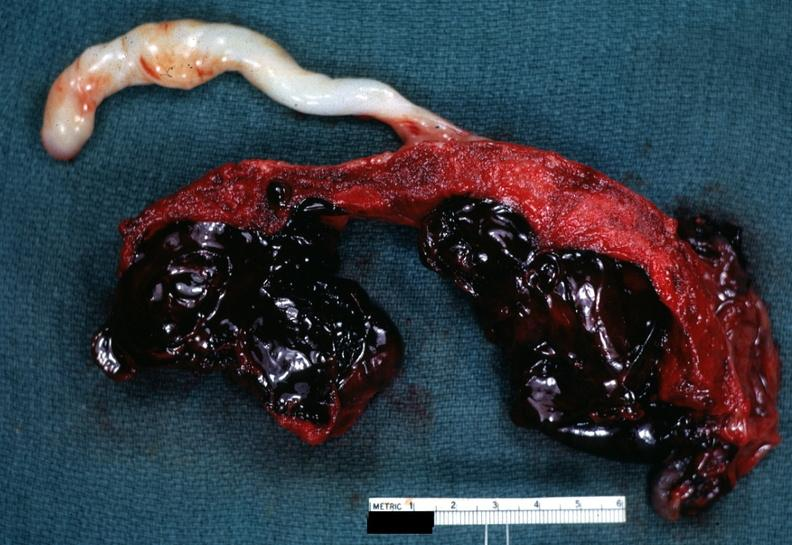does this image show saggital section which is a very good illustration of this lesion?
Answer the question using a single word or phrase. Yes 